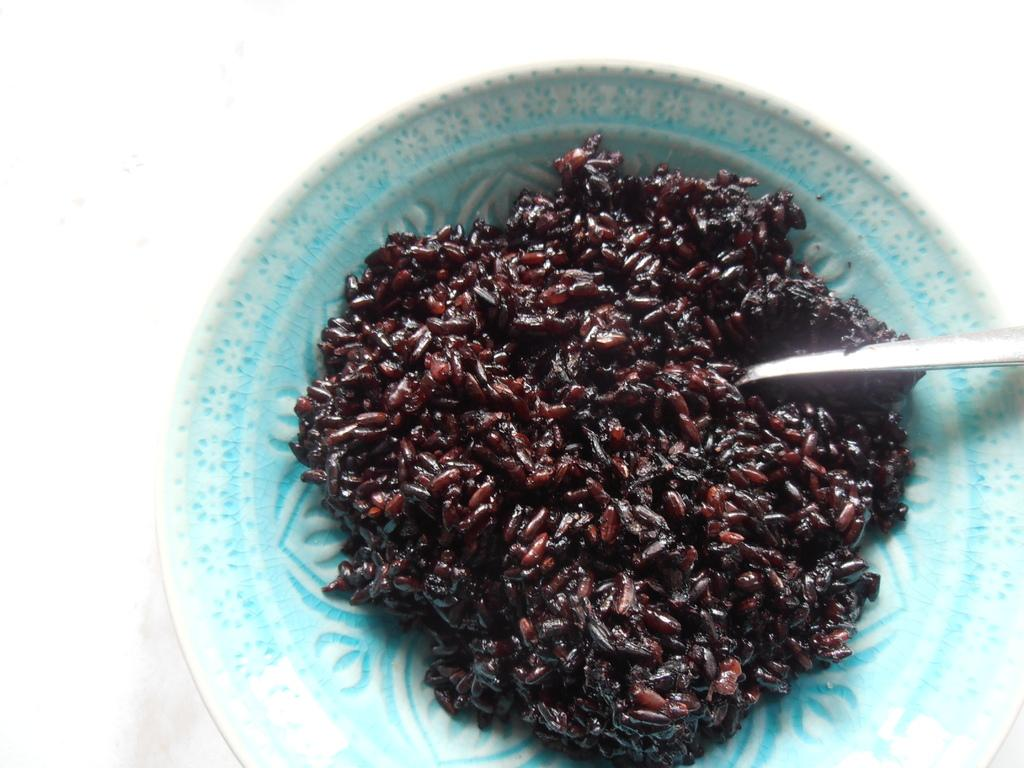What is on the plate that is visible in the image? There is a food item on the plate in the image. What utensil is placed with the food item on the plate? There is a spoon on the plate in the image. On what surface is the plate placed? The plate is placed on a white surface in the image. How much does the dime on the street cost in the image? There is no dime or street present in the image; it only features a plate with a food item and a spoon on a white surface. 